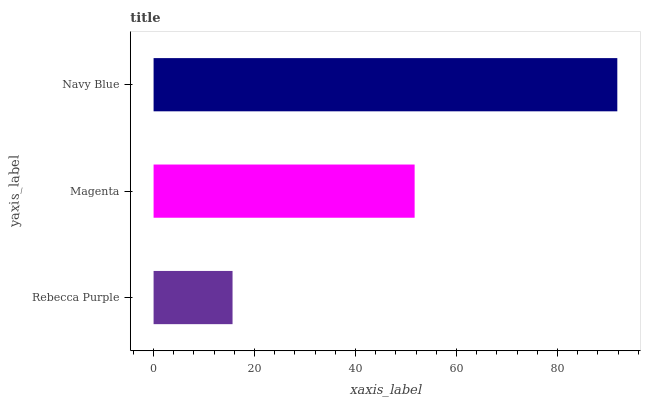Is Rebecca Purple the minimum?
Answer yes or no. Yes. Is Navy Blue the maximum?
Answer yes or no. Yes. Is Magenta the minimum?
Answer yes or no. No. Is Magenta the maximum?
Answer yes or no. No. Is Magenta greater than Rebecca Purple?
Answer yes or no. Yes. Is Rebecca Purple less than Magenta?
Answer yes or no. Yes. Is Rebecca Purple greater than Magenta?
Answer yes or no. No. Is Magenta less than Rebecca Purple?
Answer yes or no. No. Is Magenta the high median?
Answer yes or no. Yes. Is Magenta the low median?
Answer yes or no. Yes. Is Rebecca Purple the high median?
Answer yes or no. No. Is Rebecca Purple the low median?
Answer yes or no. No. 